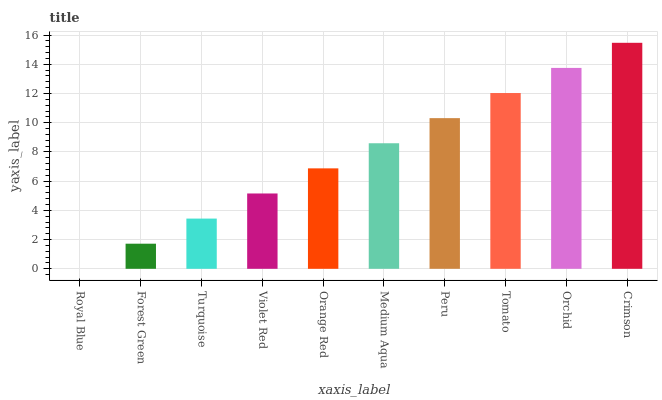Is Royal Blue the minimum?
Answer yes or no. Yes. Is Crimson the maximum?
Answer yes or no. Yes. Is Forest Green the minimum?
Answer yes or no. No. Is Forest Green the maximum?
Answer yes or no. No. Is Forest Green greater than Royal Blue?
Answer yes or no. Yes. Is Royal Blue less than Forest Green?
Answer yes or no. Yes. Is Royal Blue greater than Forest Green?
Answer yes or no. No. Is Forest Green less than Royal Blue?
Answer yes or no. No. Is Medium Aqua the high median?
Answer yes or no. Yes. Is Orange Red the low median?
Answer yes or no. Yes. Is Turquoise the high median?
Answer yes or no. No. Is Crimson the low median?
Answer yes or no. No. 